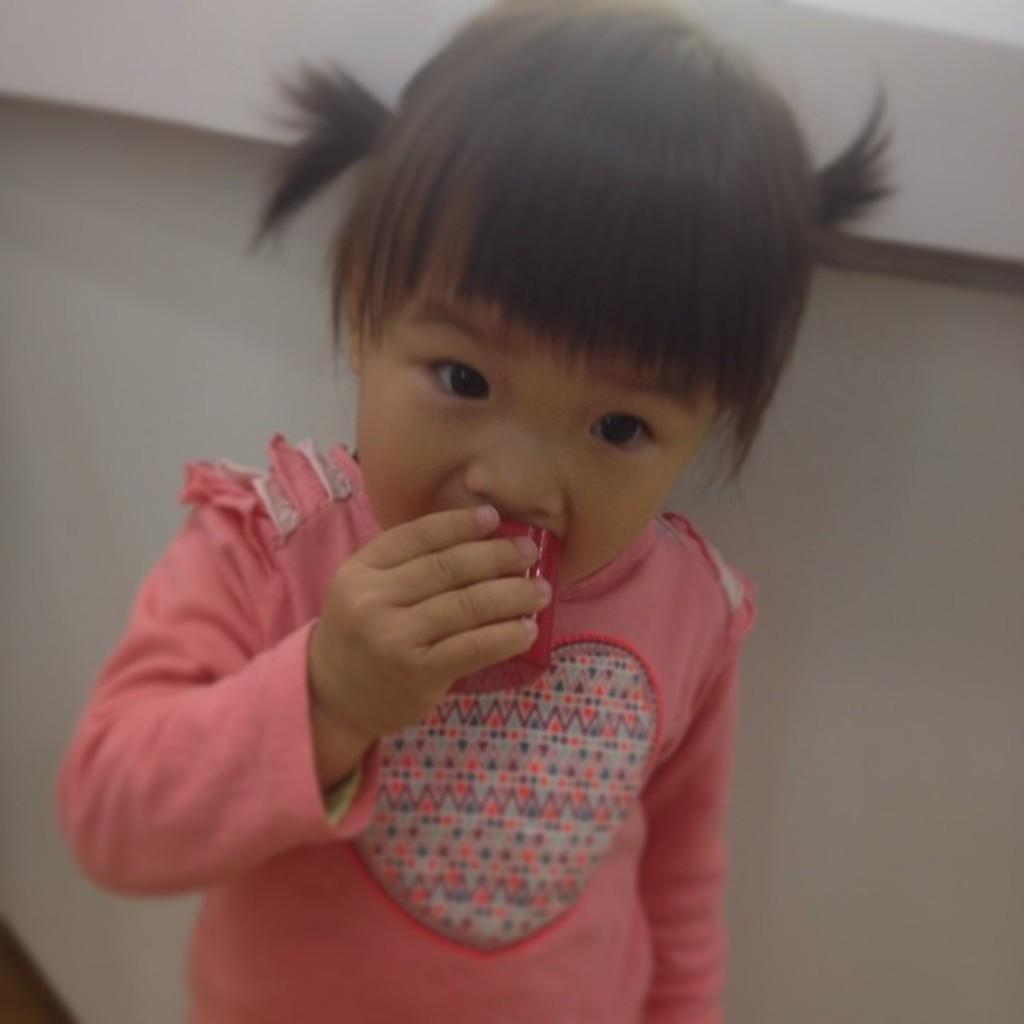What is the main subject of the image? There is a baby girl in the image. Where is the baby girl positioned in the image? The baby girl is standing in front of a table. What is the baby girl wearing? The baby girl is wearing a pink dress. What is the baby girl doing with an object in the image? The baby girl is putting an object into her mouth. What type of grain is the baby girl eating in the image? There is no grain visible in the image, and the baby girl is putting an object into her mouth, not eating grain. 